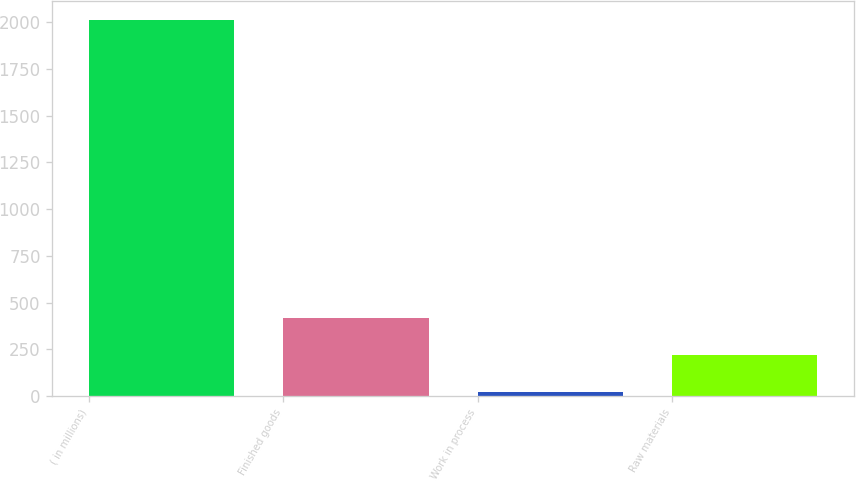<chart> <loc_0><loc_0><loc_500><loc_500><bar_chart><fcel>( in millions)<fcel>Finished goods<fcel>Work in process<fcel>Raw materials<nl><fcel>2011<fcel>417.88<fcel>19.6<fcel>218.74<nl></chart> 